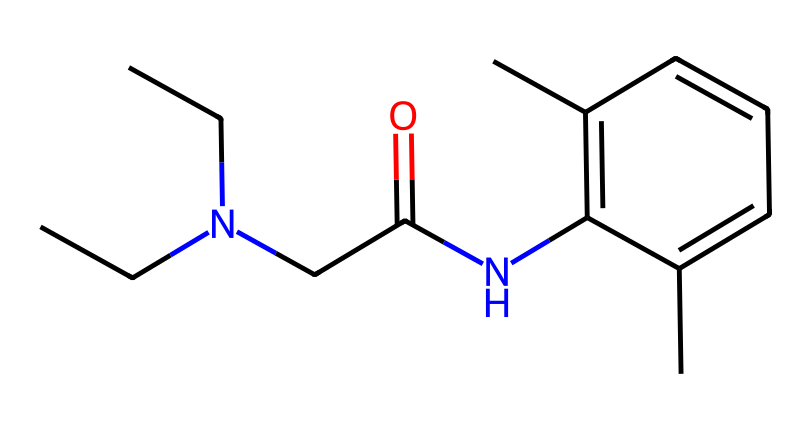What is the molecular formula of lidocaine? To determine the molecular formula from the SMILES notation, count the number of each type of atom represented. The molecule has 14 Carbon (C), 22 Hydrogen (H), 2 Nitrogen (N), and 1 Oxygen (O) atom. Thus, the molecular formula is C14H22N2O.
Answer: C14H22N2O How many nitrogen atoms are present in the structure? Inspecting the SMILES representation, there are two explicit instances of 'N' which indicate the presence of nitrogen atoms. Thus, the count is two.
Answer: 2 What type of amine is lidocaine classified as? From the structure, lidocaine has a nitrogen atom bonded to two carbon chains and a hydrogen atom, indicating it's a tert-amine (tertiary amine).
Answer: tertiary amine Does lidocaine contain any aromatic rings? The chemical structure shows a ‘c’ notation in the SMILES, which indicates the presence of aromatic carbon atoms. Specifically, there is a benzene ring represented in the structure.
Answer: yes How many carbon atoms are part of the aromatic ring in lidocaine? By analyzing the aromatic part of the structure, which includes six 'c' symbols in a cyclic arrangement, the benzene ring has six carbon atoms.
Answer: 6 What functional group is indicated by the "C(=O)N" in the structure? The notation "C(=O)N" refers to an amide functional group where a carbon atom is double-bonded to oxygen and single-bonded to nitrogen. This indicates the presence of an amide in lidocaine.
Answer: amide Is lidocaine considered hazardous? Lidocaine is classified under hazardous materials due to potential toxicity and side effects when misused, especially in higher concentrations or inappropriate contexts.
Answer: yes 